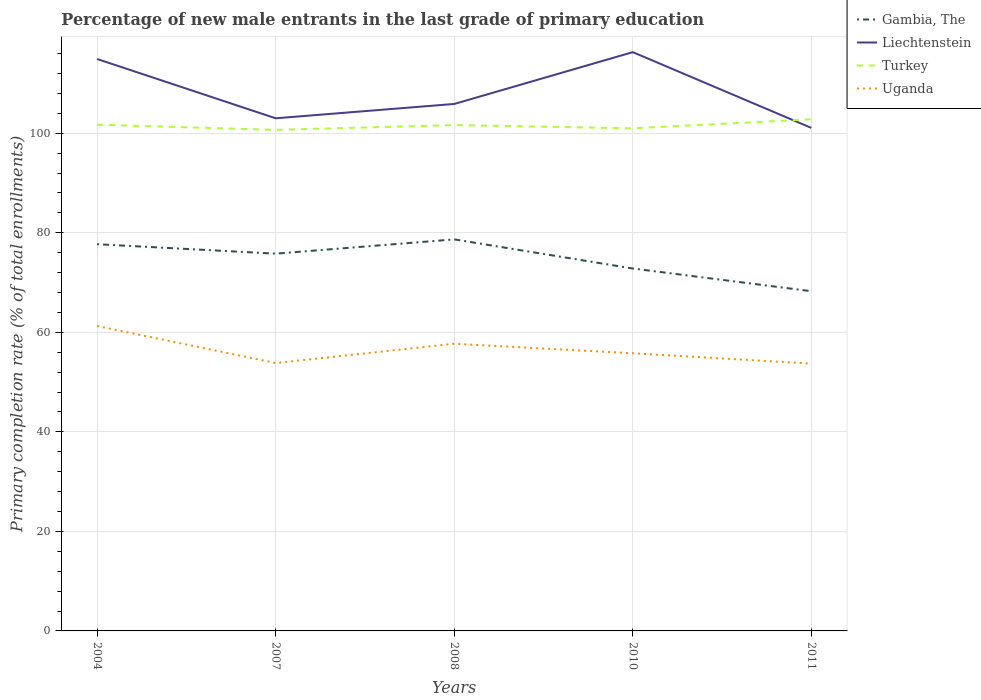How many different coloured lines are there?
Provide a succinct answer. 4. Does the line corresponding to Turkey intersect with the line corresponding to Liechtenstein?
Offer a terse response. Yes. Across all years, what is the maximum percentage of new male entrants in Uganda?
Your answer should be very brief. 53.71. In which year was the percentage of new male entrants in Liechtenstein maximum?
Offer a terse response. 2011. What is the total percentage of new male entrants in Uganda in the graph?
Give a very brief answer. 7.56. What is the difference between the highest and the second highest percentage of new male entrants in Gambia, The?
Keep it short and to the point. 10.41. Are the values on the major ticks of Y-axis written in scientific E-notation?
Your answer should be very brief. No. Does the graph contain any zero values?
Keep it short and to the point. No. Does the graph contain grids?
Provide a succinct answer. Yes. Where does the legend appear in the graph?
Offer a terse response. Top right. How are the legend labels stacked?
Keep it short and to the point. Vertical. What is the title of the graph?
Your answer should be very brief. Percentage of new male entrants in the last grade of primary education. What is the label or title of the X-axis?
Your answer should be very brief. Years. What is the label or title of the Y-axis?
Provide a succinct answer. Primary completion rate (% of total enrollments). What is the Primary completion rate (% of total enrollments) of Gambia, The in 2004?
Provide a succinct answer. 77.7. What is the Primary completion rate (% of total enrollments) of Liechtenstein in 2004?
Your answer should be compact. 114.92. What is the Primary completion rate (% of total enrollments) in Turkey in 2004?
Your response must be concise. 101.72. What is the Primary completion rate (% of total enrollments) of Uganda in 2004?
Provide a succinct answer. 61.27. What is the Primary completion rate (% of total enrollments) of Gambia, The in 2007?
Make the answer very short. 75.8. What is the Primary completion rate (% of total enrollments) in Liechtenstein in 2007?
Your answer should be compact. 103. What is the Primary completion rate (% of total enrollments) of Turkey in 2007?
Provide a short and direct response. 100.67. What is the Primary completion rate (% of total enrollments) in Uganda in 2007?
Offer a very short reply. 53.83. What is the Primary completion rate (% of total enrollments) in Gambia, The in 2008?
Ensure brevity in your answer.  78.67. What is the Primary completion rate (% of total enrollments) of Liechtenstein in 2008?
Give a very brief answer. 105.88. What is the Primary completion rate (% of total enrollments) in Turkey in 2008?
Provide a succinct answer. 101.64. What is the Primary completion rate (% of total enrollments) in Uganda in 2008?
Ensure brevity in your answer.  57.7. What is the Primary completion rate (% of total enrollments) in Gambia, The in 2010?
Make the answer very short. 72.82. What is the Primary completion rate (% of total enrollments) of Liechtenstein in 2010?
Provide a succinct answer. 116.29. What is the Primary completion rate (% of total enrollments) of Turkey in 2010?
Provide a succinct answer. 100.99. What is the Primary completion rate (% of total enrollments) in Uganda in 2010?
Offer a terse response. 55.79. What is the Primary completion rate (% of total enrollments) of Gambia, The in 2011?
Your response must be concise. 68.26. What is the Primary completion rate (% of total enrollments) in Liechtenstein in 2011?
Provide a short and direct response. 101.07. What is the Primary completion rate (% of total enrollments) of Turkey in 2011?
Give a very brief answer. 102.81. What is the Primary completion rate (% of total enrollments) in Uganda in 2011?
Your answer should be very brief. 53.71. Across all years, what is the maximum Primary completion rate (% of total enrollments) in Gambia, The?
Give a very brief answer. 78.67. Across all years, what is the maximum Primary completion rate (% of total enrollments) in Liechtenstein?
Your answer should be compact. 116.29. Across all years, what is the maximum Primary completion rate (% of total enrollments) of Turkey?
Provide a succinct answer. 102.81. Across all years, what is the maximum Primary completion rate (% of total enrollments) in Uganda?
Your answer should be very brief. 61.27. Across all years, what is the minimum Primary completion rate (% of total enrollments) in Gambia, The?
Give a very brief answer. 68.26. Across all years, what is the minimum Primary completion rate (% of total enrollments) of Liechtenstein?
Your answer should be very brief. 101.07. Across all years, what is the minimum Primary completion rate (% of total enrollments) of Turkey?
Provide a succinct answer. 100.67. Across all years, what is the minimum Primary completion rate (% of total enrollments) in Uganda?
Provide a succinct answer. 53.71. What is the total Primary completion rate (% of total enrollments) in Gambia, The in the graph?
Make the answer very short. 373.25. What is the total Primary completion rate (% of total enrollments) of Liechtenstein in the graph?
Offer a terse response. 541.17. What is the total Primary completion rate (% of total enrollments) of Turkey in the graph?
Offer a very short reply. 507.82. What is the total Primary completion rate (% of total enrollments) of Uganda in the graph?
Provide a succinct answer. 282.3. What is the difference between the Primary completion rate (% of total enrollments) of Gambia, The in 2004 and that in 2007?
Make the answer very short. 1.9. What is the difference between the Primary completion rate (% of total enrollments) of Liechtenstein in 2004 and that in 2007?
Keep it short and to the point. 11.91. What is the difference between the Primary completion rate (% of total enrollments) of Turkey in 2004 and that in 2007?
Your answer should be very brief. 1.05. What is the difference between the Primary completion rate (% of total enrollments) of Uganda in 2004 and that in 2007?
Make the answer very short. 7.44. What is the difference between the Primary completion rate (% of total enrollments) of Gambia, The in 2004 and that in 2008?
Give a very brief answer. -0.97. What is the difference between the Primary completion rate (% of total enrollments) in Liechtenstein in 2004 and that in 2008?
Keep it short and to the point. 9.03. What is the difference between the Primary completion rate (% of total enrollments) of Turkey in 2004 and that in 2008?
Offer a very short reply. 0.09. What is the difference between the Primary completion rate (% of total enrollments) in Uganda in 2004 and that in 2008?
Offer a terse response. 3.56. What is the difference between the Primary completion rate (% of total enrollments) of Gambia, The in 2004 and that in 2010?
Give a very brief answer. 4.88. What is the difference between the Primary completion rate (% of total enrollments) of Liechtenstein in 2004 and that in 2010?
Provide a short and direct response. -1.38. What is the difference between the Primary completion rate (% of total enrollments) in Turkey in 2004 and that in 2010?
Offer a terse response. 0.73. What is the difference between the Primary completion rate (% of total enrollments) in Uganda in 2004 and that in 2010?
Provide a short and direct response. 5.48. What is the difference between the Primary completion rate (% of total enrollments) in Gambia, The in 2004 and that in 2011?
Provide a short and direct response. 9.45. What is the difference between the Primary completion rate (% of total enrollments) of Liechtenstein in 2004 and that in 2011?
Offer a terse response. 13.85. What is the difference between the Primary completion rate (% of total enrollments) of Turkey in 2004 and that in 2011?
Your answer should be very brief. -1.08. What is the difference between the Primary completion rate (% of total enrollments) of Uganda in 2004 and that in 2011?
Ensure brevity in your answer.  7.56. What is the difference between the Primary completion rate (% of total enrollments) of Gambia, The in 2007 and that in 2008?
Provide a succinct answer. -2.87. What is the difference between the Primary completion rate (% of total enrollments) in Liechtenstein in 2007 and that in 2008?
Your response must be concise. -2.88. What is the difference between the Primary completion rate (% of total enrollments) of Turkey in 2007 and that in 2008?
Provide a succinct answer. -0.97. What is the difference between the Primary completion rate (% of total enrollments) in Uganda in 2007 and that in 2008?
Ensure brevity in your answer.  -3.87. What is the difference between the Primary completion rate (% of total enrollments) of Gambia, The in 2007 and that in 2010?
Ensure brevity in your answer.  2.98. What is the difference between the Primary completion rate (% of total enrollments) of Liechtenstein in 2007 and that in 2010?
Your answer should be very brief. -13.29. What is the difference between the Primary completion rate (% of total enrollments) in Turkey in 2007 and that in 2010?
Provide a succinct answer. -0.32. What is the difference between the Primary completion rate (% of total enrollments) in Uganda in 2007 and that in 2010?
Your answer should be compact. -1.96. What is the difference between the Primary completion rate (% of total enrollments) of Gambia, The in 2007 and that in 2011?
Offer a very short reply. 7.54. What is the difference between the Primary completion rate (% of total enrollments) of Liechtenstein in 2007 and that in 2011?
Ensure brevity in your answer.  1.93. What is the difference between the Primary completion rate (% of total enrollments) of Turkey in 2007 and that in 2011?
Keep it short and to the point. -2.14. What is the difference between the Primary completion rate (% of total enrollments) of Uganda in 2007 and that in 2011?
Offer a very short reply. 0.12. What is the difference between the Primary completion rate (% of total enrollments) in Gambia, The in 2008 and that in 2010?
Your answer should be very brief. 5.85. What is the difference between the Primary completion rate (% of total enrollments) in Liechtenstein in 2008 and that in 2010?
Offer a terse response. -10.41. What is the difference between the Primary completion rate (% of total enrollments) of Turkey in 2008 and that in 2010?
Keep it short and to the point. 0.65. What is the difference between the Primary completion rate (% of total enrollments) in Uganda in 2008 and that in 2010?
Make the answer very short. 1.92. What is the difference between the Primary completion rate (% of total enrollments) in Gambia, The in 2008 and that in 2011?
Make the answer very short. 10.41. What is the difference between the Primary completion rate (% of total enrollments) in Liechtenstein in 2008 and that in 2011?
Keep it short and to the point. 4.81. What is the difference between the Primary completion rate (% of total enrollments) of Turkey in 2008 and that in 2011?
Keep it short and to the point. -1.17. What is the difference between the Primary completion rate (% of total enrollments) of Uganda in 2008 and that in 2011?
Make the answer very short. 3.99. What is the difference between the Primary completion rate (% of total enrollments) of Gambia, The in 2010 and that in 2011?
Keep it short and to the point. 4.56. What is the difference between the Primary completion rate (% of total enrollments) of Liechtenstein in 2010 and that in 2011?
Provide a short and direct response. 15.22. What is the difference between the Primary completion rate (% of total enrollments) of Turkey in 2010 and that in 2011?
Provide a succinct answer. -1.82. What is the difference between the Primary completion rate (% of total enrollments) in Uganda in 2010 and that in 2011?
Provide a succinct answer. 2.08. What is the difference between the Primary completion rate (% of total enrollments) in Gambia, The in 2004 and the Primary completion rate (% of total enrollments) in Liechtenstein in 2007?
Make the answer very short. -25.3. What is the difference between the Primary completion rate (% of total enrollments) in Gambia, The in 2004 and the Primary completion rate (% of total enrollments) in Turkey in 2007?
Give a very brief answer. -22.97. What is the difference between the Primary completion rate (% of total enrollments) of Gambia, The in 2004 and the Primary completion rate (% of total enrollments) of Uganda in 2007?
Provide a succinct answer. 23.87. What is the difference between the Primary completion rate (% of total enrollments) of Liechtenstein in 2004 and the Primary completion rate (% of total enrollments) of Turkey in 2007?
Give a very brief answer. 14.25. What is the difference between the Primary completion rate (% of total enrollments) of Liechtenstein in 2004 and the Primary completion rate (% of total enrollments) of Uganda in 2007?
Give a very brief answer. 61.09. What is the difference between the Primary completion rate (% of total enrollments) of Turkey in 2004 and the Primary completion rate (% of total enrollments) of Uganda in 2007?
Your answer should be compact. 47.89. What is the difference between the Primary completion rate (% of total enrollments) in Gambia, The in 2004 and the Primary completion rate (% of total enrollments) in Liechtenstein in 2008?
Keep it short and to the point. -28.18. What is the difference between the Primary completion rate (% of total enrollments) of Gambia, The in 2004 and the Primary completion rate (% of total enrollments) of Turkey in 2008?
Offer a terse response. -23.93. What is the difference between the Primary completion rate (% of total enrollments) in Gambia, The in 2004 and the Primary completion rate (% of total enrollments) in Uganda in 2008?
Offer a very short reply. 20. What is the difference between the Primary completion rate (% of total enrollments) of Liechtenstein in 2004 and the Primary completion rate (% of total enrollments) of Turkey in 2008?
Provide a short and direct response. 13.28. What is the difference between the Primary completion rate (% of total enrollments) of Liechtenstein in 2004 and the Primary completion rate (% of total enrollments) of Uganda in 2008?
Offer a terse response. 57.22. What is the difference between the Primary completion rate (% of total enrollments) in Turkey in 2004 and the Primary completion rate (% of total enrollments) in Uganda in 2008?
Your answer should be very brief. 44.02. What is the difference between the Primary completion rate (% of total enrollments) in Gambia, The in 2004 and the Primary completion rate (% of total enrollments) in Liechtenstein in 2010?
Provide a short and direct response. -38.59. What is the difference between the Primary completion rate (% of total enrollments) of Gambia, The in 2004 and the Primary completion rate (% of total enrollments) of Turkey in 2010?
Provide a succinct answer. -23.28. What is the difference between the Primary completion rate (% of total enrollments) in Gambia, The in 2004 and the Primary completion rate (% of total enrollments) in Uganda in 2010?
Offer a very short reply. 21.92. What is the difference between the Primary completion rate (% of total enrollments) in Liechtenstein in 2004 and the Primary completion rate (% of total enrollments) in Turkey in 2010?
Ensure brevity in your answer.  13.93. What is the difference between the Primary completion rate (% of total enrollments) in Liechtenstein in 2004 and the Primary completion rate (% of total enrollments) in Uganda in 2010?
Provide a succinct answer. 59.13. What is the difference between the Primary completion rate (% of total enrollments) in Turkey in 2004 and the Primary completion rate (% of total enrollments) in Uganda in 2010?
Your answer should be very brief. 45.94. What is the difference between the Primary completion rate (% of total enrollments) of Gambia, The in 2004 and the Primary completion rate (% of total enrollments) of Liechtenstein in 2011?
Keep it short and to the point. -23.37. What is the difference between the Primary completion rate (% of total enrollments) of Gambia, The in 2004 and the Primary completion rate (% of total enrollments) of Turkey in 2011?
Provide a succinct answer. -25.1. What is the difference between the Primary completion rate (% of total enrollments) of Gambia, The in 2004 and the Primary completion rate (% of total enrollments) of Uganda in 2011?
Ensure brevity in your answer.  23.99. What is the difference between the Primary completion rate (% of total enrollments) of Liechtenstein in 2004 and the Primary completion rate (% of total enrollments) of Turkey in 2011?
Your response must be concise. 12.11. What is the difference between the Primary completion rate (% of total enrollments) of Liechtenstein in 2004 and the Primary completion rate (% of total enrollments) of Uganda in 2011?
Your answer should be compact. 61.21. What is the difference between the Primary completion rate (% of total enrollments) in Turkey in 2004 and the Primary completion rate (% of total enrollments) in Uganda in 2011?
Ensure brevity in your answer.  48.01. What is the difference between the Primary completion rate (% of total enrollments) in Gambia, The in 2007 and the Primary completion rate (% of total enrollments) in Liechtenstein in 2008?
Provide a succinct answer. -30.08. What is the difference between the Primary completion rate (% of total enrollments) of Gambia, The in 2007 and the Primary completion rate (% of total enrollments) of Turkey in 2008?
Make the answer very short. -25.84. What is the difference between the Primary completion rate (% of total enrollments) in Gambia, The in 2007 and the Primary completion rate (% of total enrollments) in Uganda in 2008?
Offer a terse response. 18.1. What is the difference between the Primary completion rate (% of total enrollments) in Liechtenstein in 2007 and the Primary completion rate (% of total enrollments) in Turkey in 2008?
Offer a very short reply. 1.37. What is the difference between the Primary completion rate (% of total enrollments) in Liechtenstein in 2007 and the Primary completion rate (% of total enrollments) in Uganda in 2008?
Ensure brevity in your answer.  45.3. What is the difference between the Primary completion rate (% of total enrollments) of Turkey in 2007 and the Primary completion rate (% of total enrollments) of Uganda in 2008?
Your response must be concise. 42.97. What is the difference between the Primary completion rate (% of total enrollments) of Gambia, The in 2007 and the Primary completion rate (% of total enrollments) of Liechtenstein in 2010?
Your answer should be compact. -40.49. What is the difference between the Primary completion rate (% of total enrollments) of Gambia, The in 2007 and the Primary completion rate (% of total enrollments) of Turkey in 2010?
Your response must be concise. -25.19. What is the difference between the Primary completion rate (% of total enrollments) of Gambia, The in 2007 and the Primary completion rate (% of total enrollments) of Uganda in 2010?
Offer a very short reply. 20.01. What is the difference between the Primary completion rate (% of total enrollments) in Liechtenstein in 2007 and the Primary completion rate (% of total enrollments) in Turkey in 2010?
Your answer should be very brief. 2.02. What is the difference between the Primary completion rate (% of total enrollments) of Liechtenstein in 2007 and the Primary completion rate (% of total enrollments) of Uganda in 2010?
Your answer should be compact. 47.22. What is the difference between the Primary completion rate (% of total enrollments) of Turkey in 2007 and the Primary completion rate (% of total enrollments) of Uganda in 2010?
Offer a terse response. 44.88. What is the difference between the Primary completion rate (% of total enrollments) of Gambia, The in 2007 and the Primary completion rate (% of total enrollments) of Liechtenstein in 2011?
Make the answer very short. -25.27. What is the difference between the Primary completion rate (% of total enrollments) of Gambia, The in 2007 and the Primary completion rate (% of total enrollments) of Turkey in 2011?
Your answer should be compact. -27.01. What is the difference between the Primary completion rate (% of total enrollments) in Gambia, The in 2007 and the Primary completion rate (% of total enrollments) in Uganda in 2011?
Your response must be concise. 22.09. What is the difference between the Primary completion rate (% of total enrollments) of Liechtenstein in 2007 and the Primary completion rate (% of total enrollments) of Turkey in 2011?
Offer a very short reply. 0.2. What is the difference between the Primary completion rate (% of total enrollments) of Liechtenstein in 2007 and the Primary completion rate (% of total enrollments) of Uganda in 2011?
Make the answer very short. 49.29. What is the difference between the Primary completion rate (% of total enrollments) in Turkey in 2007 and the Primary completion rate (% of total enrollments) in Uganda in 2011?
Provide a succinct answer. 46.96. What is the difference between the Primary completion rate (% of total enrollments) in Gambia, The in 2008 and the Primary completion rate (% of total enrollments) in Liechtenstein in 2010?
Keep it short and to the point. -37.62. What is the difference between the Primary completion rate (% of total enrollments) of Gambia, The in 2008 and the Primary completion rate (% of total enrollments) of Turkey in 2010?
Provide a short and direct response. -22.32. What is the difference between the Primary completion rate (% of total enrollments) in Gambia, The in 2008 and the Primary completion rate (% of total enrollments) in Uganda in 2010?
Give a very brief answer. 22.88. What is the difference between the Primary completion rate (% of total enrollments) of Liechtenstein in 2008 and the Primary completion rate (% of total enrollments) of Turkey in 2010?
Keep it short and to the point. 4.89. What is the difference between the Primary completion rate (% of total enrollments) in Liechtenstein in 2008 and the Primary completion rate (% of total enrollments) in Uganda in 2010?
Provide a short and direct response. 50.1. What is the difference between the Primary completion rate (% of total enrollments) in Turkey in 2008 and the Primary completion rate (% of total enrollments) in Uganda in 2010?
Your answer should be very brief. 45.85. What is the difference between the Primary completion rate (% of total enrollments) in Gambia, The in 2008 and the Primary completion rate (% of total enrollments) in Liechtenstein in 2011?
Give a very brief answer. -22.4. What is the difference between the Primary completion rate (% of total enrollments) of Gambia, The in 2008 and the Primary completion rate (% of total enrollments) of Turkey in 2011?
Ensure brevity in your answer.  -24.13. What is the difference between the Primary completion rate (% of total enrollments) in Gambia, The in 2008 and the Primary completion rate (% of total enrollments) in Uganda in 2011?
Give a very brief answer. 24.96. What is the difference between the Primary completion rate (% of total enrollments) of Liechtenstein in 2008 and the Primary completion rate (% of total enrollments) of Turkey in 2011?
Your answer should be very brief. 3.08. What is the difference between the Primary completion rate (% of total enrollments) in Liechtenstein in 2008 and the Primary completion rate (% of total enrollments) in Uganda in 2011?
Offer a very short reply. 52.17. What is the difference between the Primary completion rate (% of total enrollments) of Turkey in 2008 and the Primary completion rate (% of total enrollments) of Uganda in 2011?
Provide a short and direct response. 47.93. What is the difference between the Primary completion rate (% of total enrollments) of Gambia, The in 2010 and the Primary completion rate (% of total enrollments) of Liechtenstein in 2011?
Make the answer very short. -28.25. What is the difference between the Primary completion rate (% of total enrollments) of Gambia, The in 2010 and the Primary completion rate (% of total enrollments) of Turkey in 2011?
Offer a very short reply. -29.99. What is the difference between the Primary completion rate (% of total enrollments) in Gambia, The in 2010 and the Primary completion rate (% of total enrollments) in Uganda in 2011?
Give a very brief answer. 19.11. What is the difference between the Primary completion rate (% of total enrollments) in Liechtenstein in 2010 and the Primary completion rate (% of total enrollments) in Turkey in 2011?
Offer a terse response. 13.49. What is the difference between the Primary completion rate (% of total enrollments) in Liechtenstein in 2010 and the Primary completion rate (% of total enrollments) in Uganda in 2011?
Provide a short and direct response. 62.58. What is the difference between the Primary completion rate (% of total enrollments) of Turkey in 2010 and the Primary completion rate (% of total enrollments) of Uganda in 2011?
Your answer should be very brief. 47.28. What is the average Primary completion rate (% of total enrollments) of Gambia, The per year?
Provide a succinct answer. 74.65. What is the average Primary completion rate (% of total enrollments) in Liechtenstein per year?
Offer a very short reply. 108.23. What is the average Primary completion rate (% of total enrollments) of Turkey per year?
Offer a very short reply. 101.56. What is the average Primary completion rate (% of total enrollments) in Uganda per year?
Ensure brevity in your answer.  56.46. In the year 2004, what is the difference between the Primary completion rate (% of total enrollments) in Gambia, The and Primary completion rate (% of total enrollments) in Liechtenstein?
Your response must be concise. -37.21. In the year 2004, what is the difference between the Primary completion rate (% of total enrollments) of Gambia, The and Primary completion rate (% of total enrollments) of Turkey?
Provide a short and direct response. -24.02. In the year 2004, what is the difference between the Primary completion rate (% of total enrollments) in Gambia, The and Primary completion rate (% of total enrollments) in Uganda?
Provide a short and direct response. 16.44. In the year 2004, what is the difference between the Primary completion rate (% of total enrollments) of Liechtenstein and Primary completion rate (% of total enrollments) of Turkey?
Your response must be concise. 13.2. In the year 2004, what is the difference between the Primary completion rate (% of total enrollments) in Liechtenstein and Primary completion rate (% of total enrollments) in Uganda?
Provide a short and direct response. 53.65. In the year 2004, what is the difference between the Primary completion rate (% of total enrollments) in Turkey and Primary completion rate (% of total enrollments) in Uganda?
Make the answer very short. 40.45. In the year 2007, what is the difference between the Primary completion rate (% of total enrollments) of Gambia, The and Primary completion rate (% of total enrollments) of Liechtenstein?
Your answer should be compact. -27.2. In the year 2007, what is the difference between the Primary completion rate (% of total enrollments) of Gambia, The and Primary completion rate (% of total enrollments) of Turkey?
Make the answer very short. -24.87. In the year 2007, what is the difference between the Primary completion rate (% of total enrollments) in Gambia, The and Primary completion rate (% of total enrollments) in Uganda?
Make the answer very short. 21.97. In the year 2007, what is the difference between the Primary completion rate (% of total enrollments) in Liechtenstein and Primary completion rate (% of total enrollments) in Turkey?
Offer a terse response. 2.33. In the year 2007, what is the difference between the Primary completion rate (% of total enrollments) of Liechtenstein and Primary completion rate (% of total enrollments) of Uganda?
Provide a succinct answer. 49.17. In the year 2007, what is the difference between the Primary completion rate (% of total enrollments) of Turkey and Primary completion rate (% of total enrollments) of Uganda?
Offer a terse response. 46.84. In the year 2008, what is the difference between the Primary completion rate (% of total enrollments) of Gambia, The and Primary completion rate (% of total enrollments) of Liechtenstein?
Provide a short and direct response. -27.21. In the year 2008, what is the difference between the Primary completion rate (% of total enrollments) of Gambia, The and Primary completion rate (% of total enrollments) of Turkey?
Your answer should be compact. -22.96. In the year 2008, what is the difference between the Primary completion rate (% of total enrollments) of Gambia, The and Primary completion rate (% of total enrollments) of Uganda?
Your response must be concise. 20.97. In the year 2008, what is the difference between the Primary completion rate (% of total enrollments) of Liechtenstein and Primary completion rate (% of total enrollments) of Turkey?
Your answer should be compact. 4.25. In the year 2008, what is the difference between the Primary completion rate (% of total enrollments) in Liechtenstein and Primary completion rate (% of total enrollments) in Uganda?
Give a very brief answer. 48.18. In the year 2008, what is the difference between the Primary completion rate (% of total enrollments) in Turkey and Primary completion rate (% of total enrollments) in Uganda?
Your answer should be very brief. 43.93. In the year 2010, what is the difference between the Primary completion rate (% of total enrollments) in Gambia, The and Primary completion rate (% of total enrollments) in Liechtenstein?
Your answer should be very brief. -43.47. In the year 2010, what is the difference between the Primary completion rate (% of total enrollments) in Gambia, The and Primary completion rate (% of total enrollments) in Turkey?
Your answer should be compact. -28.17. In the year 2010, what is the difference between the Primary completion rate (% of total enrollments) in Gambia, The and Primary completion rate (% of total enrollments) in Uganda?
Offer a terse response. 17.03. In the year 2010, what is the difference between the Primary completion rate (% of total enrollments) of Liechtenstein and Primary completion rate (% of total enrollments) of Turkey?
Keep it short and to the point. 15.3. In the year 2010, what is the difference between the Primary completion rate (% of total enrollments) of Liechtenstein and Primary completion rate (% of total enrollments) of Uganda?
Keep it short and to the point. 60.51. In the year 2010, what is the difference between the Primary completion rate (% of total enrollments) in Turkey and Primary completion rate (% of total enrollments) in Uganda?
Make the answer very short. 45.2. In the year 2011, what is the difference between the Primary completion rate (% of total enrollments) of Gambia, The and Primary completion rate (% of total enrollments) of Liechtenstein?
Offer a very short reply. -32.81. In the year 2011, what is the difference between the Primary completion rate (% of total enrollments) of Gambia, The and Primary completion rate (% of total enrollments) of Turkey?
Give a very brief answer. -34.55. In the year 2011, what is the difference between the Primary completion rate (% of total enrollments) in Gambia, The and Primary completion rate (% of total enrollments) in Uganda?
Ensure brevity in your answer.  14.55. In the year 2011, what is the difference between the Primary completion rate (% of total enrollments) in Liechtenstein and Primary completion rate (% of total enrollments) in Turkey?
Provide a short and direct response. -1.74. In the year 2011, what is the difference between the Primary completion rate (% of total enrollments) of Liechtenstein and Primary completion rate (% of total enrollments) of Uganda?
Your answer should be compact. 47.36. In the year 2011, what is the difference between the Primary completion rate (% of total enrollments) of Turkey and Primary completion rate (% of total enrollments) of Uganda?
Provide a succinct answer. 49.09. What is the ratio of the Primary completion rate (% of total enrollments) of Gambia, The in 2004 to that in 2007?
Keep it short and to the point. 1.03. What is the ratio of the Primary completion rate (% of total enrollments) in Liechtenstein in 2004 to that in 2007?
Your answer should be compact. 1.12. What is the ratio of the Primary completion rate (% of total enrollments) in Turkey in 2004 to that in 2007?
Keep it short and to the point. 1.01. What is the ratio of the Primary completion rate (% of total enrollments) of Uganda in 2004 to that in 2007?
Provide a succinct answer. 1.14. What is the ratio of the Primary completion rate (% of total enrollments) in Gambia, The in 2004 to that in 2008?
Make the answer very short. 0.99. What is the ratio of the Primary completion rate (% of total enrollments) of Liechtenstein in 2004 to that in 2008?
Ensure brevity in your answer.  1.09. What is the ratio of the Primary completion rate (% of total enrollments) of Uganda in 2004 to that in 2008?
Give a very brief answer. 1.06. What is the ratio of the Primary completion rate (% of total enrollments) of Gambia, The in 2004 to that in 2010?
Offer a terse response. 1.07. What is the ratio of the Primary completion rate (% of total enrollments) of Turkey in 2004 to that in 2010?
Give a very brief answer. 1.01. What is the ratio of the Primary completion rate (% of total enrollments) in Uganda in 2004 to that in 2010?
Keep it short and to the point. 1.1. What is the ratio of the Primary completion rate (% of total enrollments) of Gambia, The in 2004 to that in 2011?
Ensure brevity in your answer.  1.14. What is the ratio of the Primary completion rate (% of total enrollments) of Liechtenstein in 2004 to that in 2011?
Provide a succinct answer. 1.14. What is the ratio of the Primary completion rate (% of total enrollments) in Turkey in 2004 to that in 2011?
Your response must be concise. 0.99. What is the ratio of the Primary completion rate (% of total enrollments) of Uganda in 2004 to that in 2011?
Provide a succinct answer. 1.14. What is the ratio of the Primary completion rate (% of total enrollments) in Gambia, The in 2007 to that in 2008?
Offer a terse response. 0.96. What is the ratio of the Primary completion rate (% of total enrollments) in Liechtenstein in 2007 to that in 2008?
Give a very brief answer. 0.97. What is the ratio of the Primary completion rate (% of total enrollments) of Uganda in 2007 to that in 2008?
Offer a terse response. 0.93. What is the ratio of the Primary completion rate (% of total enrollments) of Gambia, The in 2007 to that in 2010?
Provide a succinct answer. 1.04. What is the ratio of the Primary completion rate (% of total enrollments) of Liechtenstein in 2007 to that in 2010?
Give a very brief answer. 0.89. What is the ratio of the Primary completion rate (% of total enrollments) of Turkey in 2007 to that in 2010?
Keep it short and to the point. 1. What is the ratio of the Primary completion rate (% of total enrollments) in Uganda in 2007 to that in 2010?
Offer a very short reply. 0.96. What is the ratio of the Primary completion rate (% of total enrollments) of Gambia, The in 2007 to that in 2011?
Make the answer very short. 1.11. What is the ratio of the Primary completion rate (% of total enrollments) of Liechtenstein in 2007 to that in 2011?
Your response must be concise. 1.02. What is the ratio of the Primary completion rate (% of total enrollments) in Turkey in 2007 to that in 2011?
Make the answer very short. 0.98. What is the ratio of the Primary completion rate (% of total enrollments) in Uganda in 2007 to that in 2011?
Your response must be concise. 1. What is the ratio of the Primary completion rate (% of total enrollments) of Gambia, The in 2008 to that in 2010?
Offer a very short reply. 1.08. What is the ratio of the Primary completion rate (% of total enrollments) in Liechtenstein in 2008 to that in 2010?
Give a very brief answer. 0.91. What is the ratio of the Primary completion rate (% of total enrollments) in Turkey in 2008 to that in 2010?
Your answer should be very brief. 1.01. What is the ratio of the Primary completion rate (% of total enrollments) of Uganda in 2008 to that in 2010?
Keep it short and to the point. 1.03. What is the ratio of the Primary completion rate (% of total enrollments) in Gambia, The in 2008 to that in 2011?
Your answer should be compact. 1.15. What is the ratio of the Primary completion rate (% of total enrollments) in Liechtenstein in 2008 to that in 2011?
Offer a very short reply. 1.05. What is the ratio of the Primary completion rate (% of total enrollments) in Uganda in 2008 to that in 2011?
Ensure brevity in your answer.  1.07. What is the ratio of the Primary completion rate (% of total enrollments) in Gambia, The in 2010 to that in 2011?
Ensure brevity in your answer.  1.07. What is the ratio of the Primary completion rate (% of total enrollments) in Liechtenstein in 2010 to that in 2011?
Your response must be concise. 1.15. What is the ratio of the Primary completion rate (% of total enrollments) of Turkey in 2010 to that in 2011?
Your answer should be compact. 0.98. What is the ratio of the Primary completion rate (% of total enrollments) in Uganda in 2010 to that in 2011?
Provide a short and direct response. 1.04. What is the difference between the highest and the second highest Primary completion rate (% of total enrollments) of Gambia, The?
Provide a short and direct response. 0.97. What is the difference between the highest and the second highest Primary completion rate (% of total enrollments) in Liechtenstein?
Provide a short and direct response. 1.38. What is the difference between the highest and the second highest Primary completion rate (% of total enrollments) in Turkey?
Offer a terse response. 1.08. What is the difference between the highest and the second highest Primary completion rate (% of total enrollments) in Uganda?
Your answer should be compact. 3.56. What is the difference between the highest and the lowest Primary completion rate (% of total enrollments) of Gambia, The?
Provide a short and direct response. 10.41. What is the difference between the highest and the lowest Primary completion rate (% of total enrollments) of Liechtenstein?
Offer a terse response. 15.22. What is the difference between the highest and the lowest Primary completion rate (% of total enrollments) of Turkey?
Provide a short and direct response. 2.14. What is the difference between the highest and the lowest Primary completion rate (% of total enrollments) of Uganda?
Offer a very short reply. 7.56. 